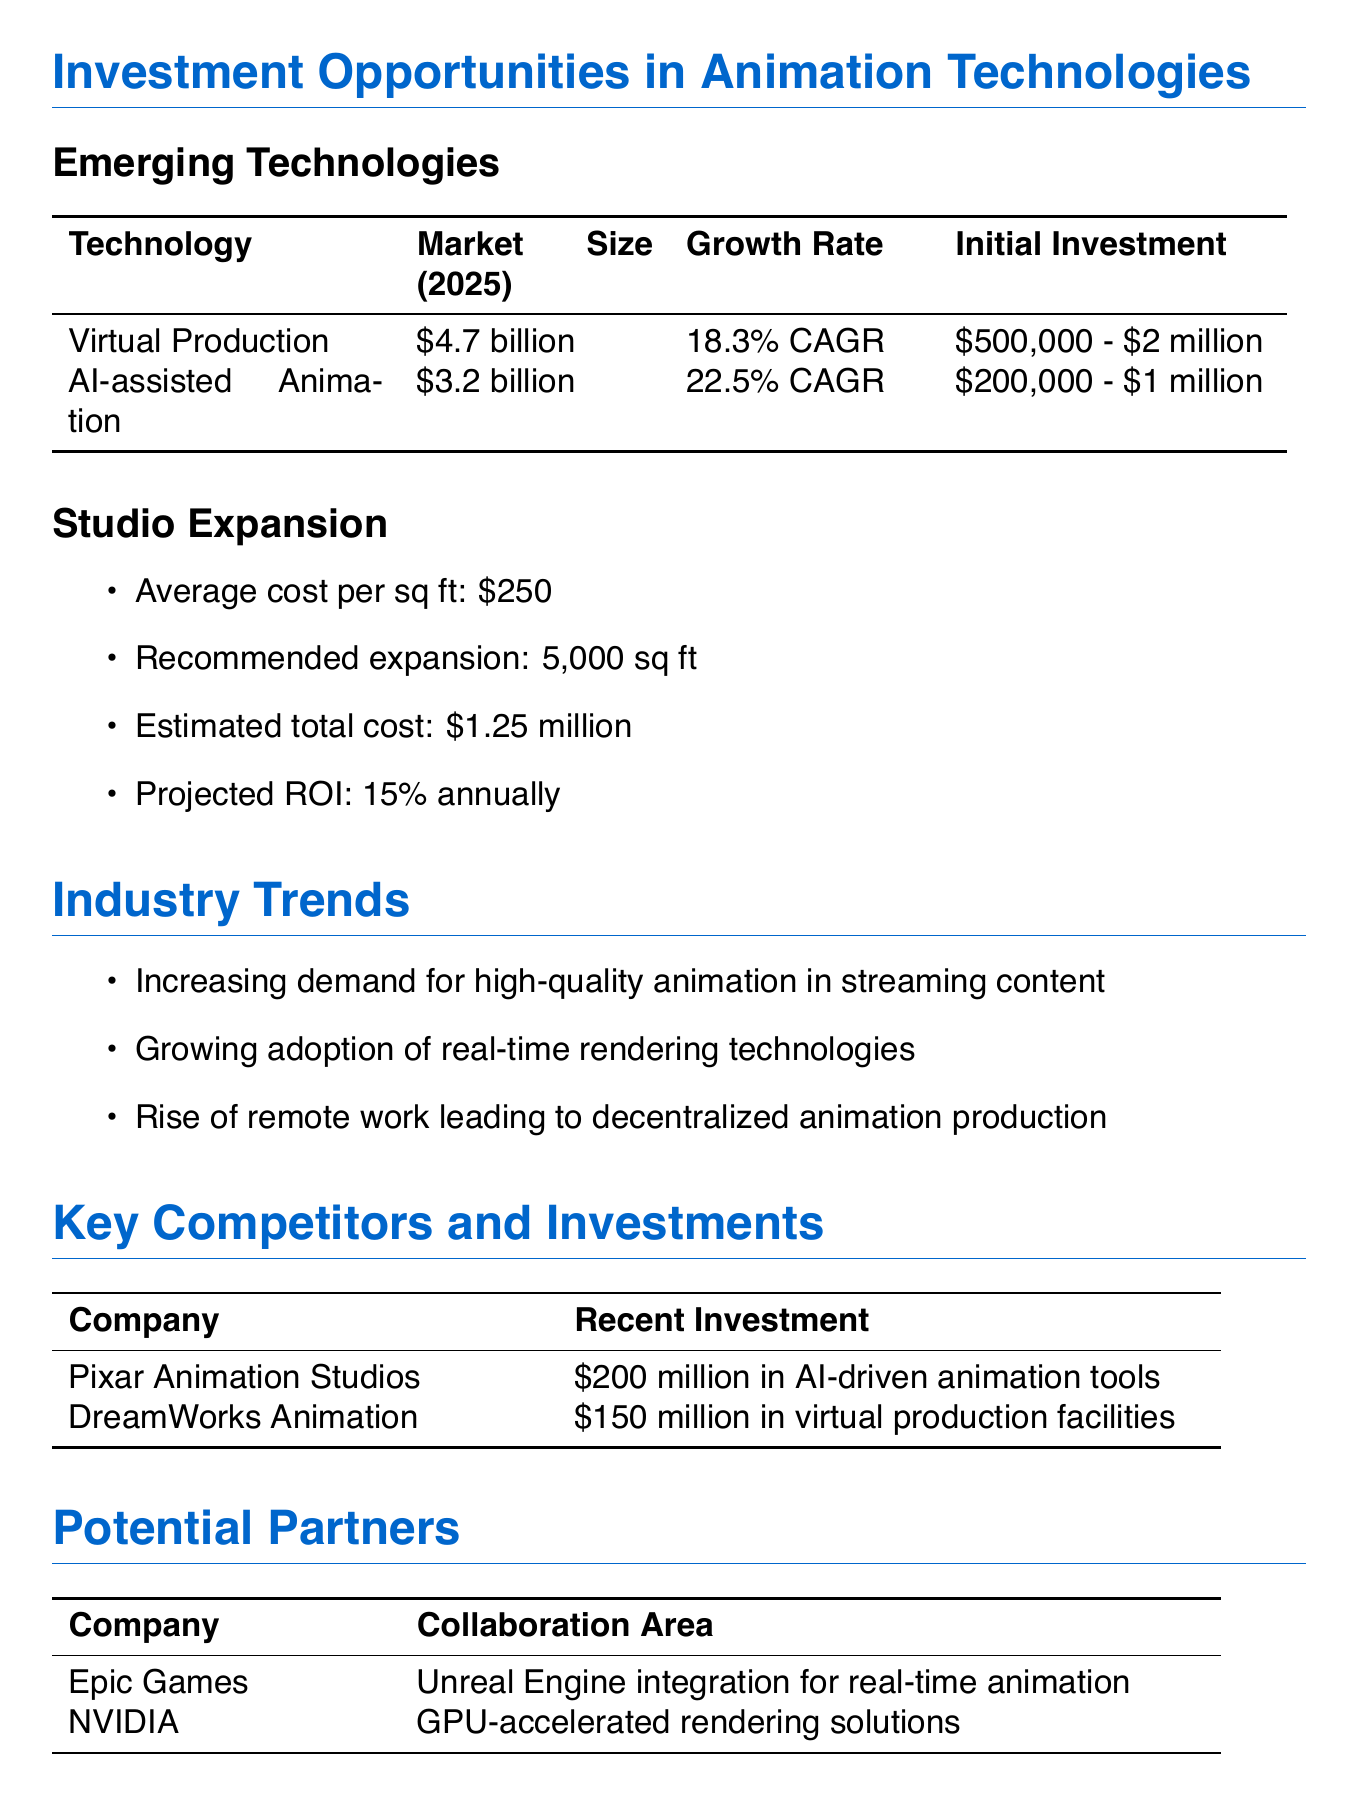what is the estimated market size for Virtual Production in 2025? The estimated market size for Virtual Production in 2025 is explicitly stated in the document.
Answer: $4.7 billion what is the projected growth rate for AI-assisted Animation? The growth rate of AI-assisted Animation is provided in the emerging technologies section of the document.
Answer: 22.5% CAGR what is the average cost per square foot for studio expansion? The average cost per square foot is detailed in the studio expansion section.
Answer: $250 what is the recommended expansion size in square feet? The recommended expansion size is mentioned in the studio expansion section of the document.
Answer: 5,000 sq ft which company invested $200 million in AI-driven animation tools? The company that made this investment is listed in the key competitors and investments section of the document.
Answer: Pixar Animation Studios what are the potential areas of collaboration with Epic Games? The document specifies the collaboration area with Epic Games under potential partners.
Answer: Unreal Engine integration for real-time animation what is one market opportunity identified in the report? Market opportunities are listed in a specific section of the document.
Answer: Expansion into video game cinematics production what are the two risk factors mentioned in the report? The document directly lists the risk factors, and both are provided under a specific section.
Answer: Rapid technological advancements and Increased competition from emerging markets with lower labor costs what is the estimated total cost for studio expansion? The estimated total cost is provided under the studio expansion section of the document.
Answer: $1.25 million 